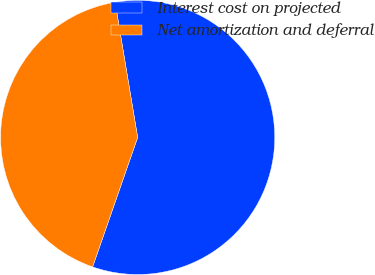Convert chart to OTSL. <chart><loc_0><loc_0><loc_500><loc_500><pie_chart><fcel>Interest cost on projected<fcel>Net amortization and deferral<nl><fcel>57.96%<fcel>42.04%<nl></chart> 